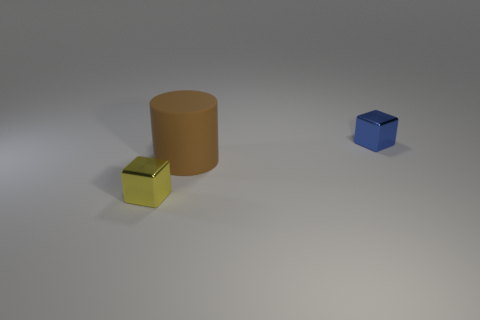Add 2 tiny purple rubber cubes. How many objects exist? 5 Subtract all cubes. How many objects are left? 1 Subtract all tiny cyan matte cubes. Subtract all yellow shiny things. How many objects are left? 2 Add 2 tiny yellow things. How many tiny yellow things are left? 3 Add 1 small blue metal blocks. How many small blue metal blocks exist? 2 Subtract 0 blue cylinders. How many objects are left? 3 